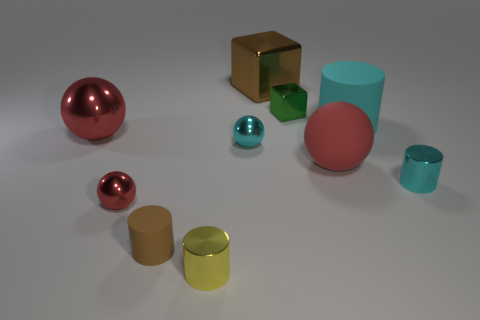Subtract all red blocks. How many cyan cylinders are left? 2 Subtract all cyan balls. How many balls are left? 3 Subtract all cyan balls. How many balls are left? 3 Subtract 2 cylinders. How many cylinders are left? 2 Subtract all cubes. How many objects are left? 8 Subtract all green cylinders. Subtract all brown balls. How many cylinders are left? 4 Subtract all tiny gray cylinders. Subtract all large blocks. How many objects are left? 9 Add 9 cyan shiny cylinders. How many cyan shiny cylinders are left? 10 Add 9 small purple metal objects. How many small purple metal objects exist? 9 Subtract 0 purple balls. How many objects are left? 10 